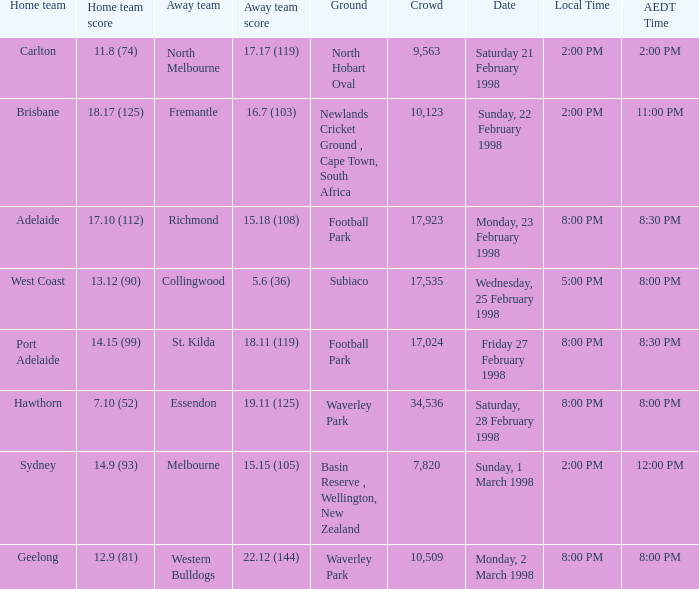Which Home team is on Wednesday, 25 february 1998? West Coast. 